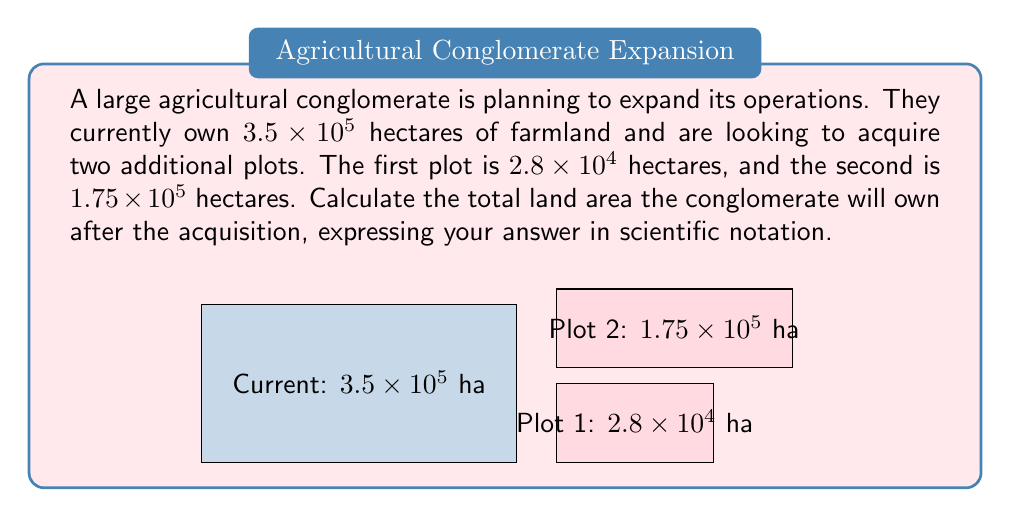Help me with this question. To solve this problem, we need to add the areas of all three land parcels and express the result in scientific notation. Let's break it down step-by-step:

1) Current land: $3.5 \times 10^5$ hectares
2) First new plot: $2.8 \times 10^4$ hectares
3) Second new plot: $1.75 \times 10^5$ hectares

Step 1: Convert all numbers to the same power of 10 (in this case, $10^5$):
- $3.5 \times 10^5$
- $2.8 \times 10^4 = 0.28 \times 10^5$
- $1.75 \times 10^5$

Step 2: Add the coefficients:
$3.5 + 0.28 + 1.75 = 5.53$

Step 3: Combine the result with the power of 10:
$5.53 \times 10^5$ hectares

This is already in proper scientific notation, as the coefficient is between 1 and 10.
Answer: $5.53 \times 10^5$ hectares 